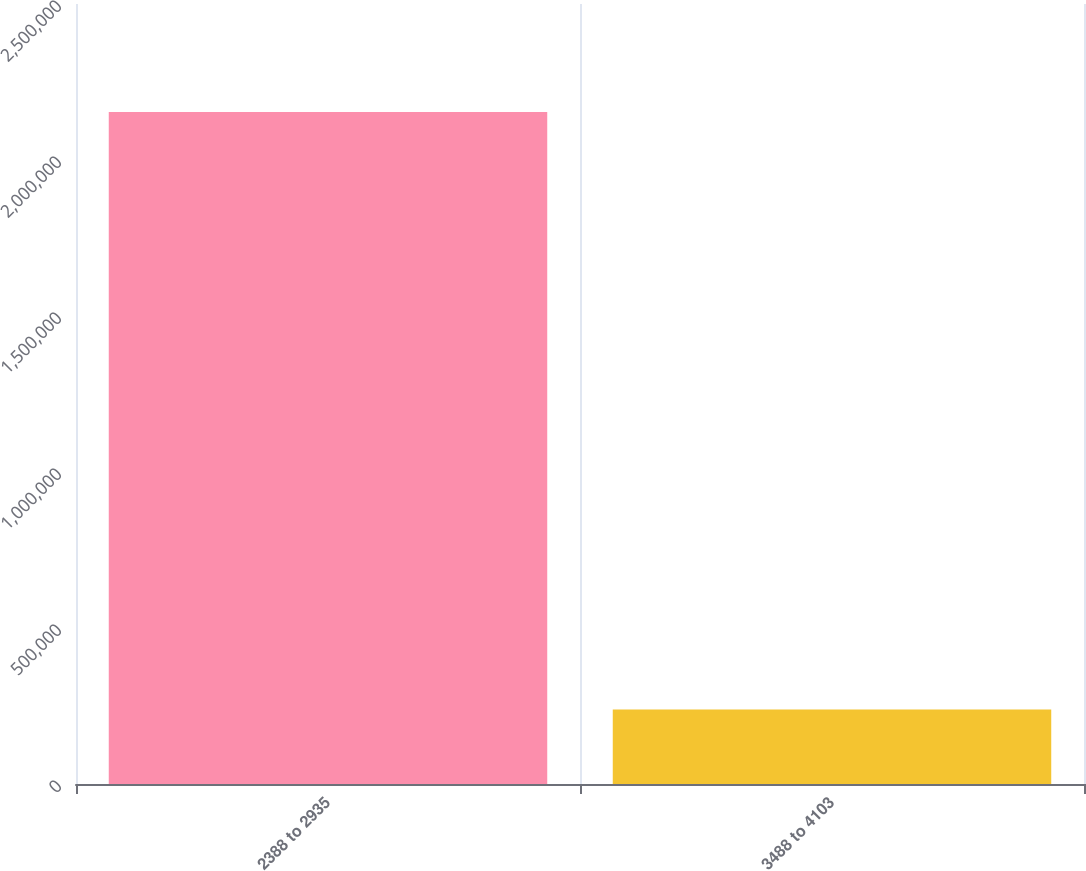Convert chart to OTSL. <chart><loc_0><loc_0><loc_500><loc_500><bar_chart><fcel>2388 to 2935<fcel>3488 to 4103<nl><fcel>2.15351e+06<fcel>238755<nl></chart> 